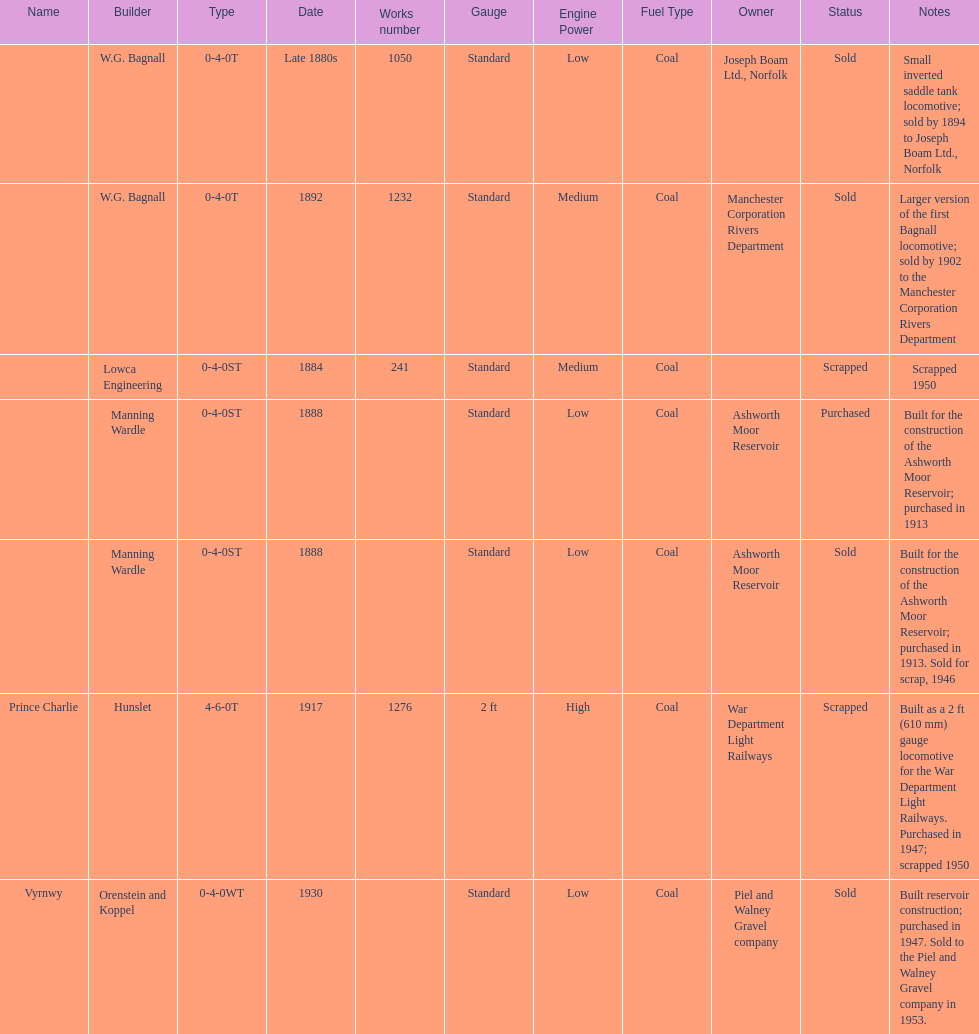How many locomotives were built before the 1900s? 5. Can you give me this table as a dict? {'header': ['Name', 'Builder', 'Type', 'Date', 'Works number', 'Gauge', 'Engine Power', 'Fuel Type', 'Owner', 'Status', 'Notes'], 'rows': [['', 'W.G. Bagnall', '0-4-0T', 'Late 1880s', '1050', 'Standard', 'Low', 'Coal', 'Joseph Boam Ltd., Norfolk', 'Sold', 'Small inverted saddle tank locomotive; sold by 1894 to Joseph Boam Ltd., Norfolk'], ['', 'W.G. Bagnall', '0-4-0T', '1892', '1232', 'Standard', 'Medium', 'Coal', 'Manchester Corporation Rivers Department', 'Sold', 'Larger version of the first Bagnall locomotive; sold by 1902 to the Manchester Corporation Rivers Department'], ['', 'Lowca Engineering', '0-4-0ST', '1884', '241', 'Standard', 'Medium', 'Coal', '', 'Scrapped', 'Scrapped 1950'], ['', 'Manning Wardle', '0-4-0ST', '1888', '', 'Standard', 'Low', 'Coal', 'Ashworth Moor Reservoir', 'Purchased', 'Built for the construction of the Ashworth Moor Reservoir; purchased in 1913'], ['', 'Manning Wardle', '0-4-0ST', '1888', '', 'Standard', 'Low', 'Coal', 'Ashworth Moor Reservoir', 'Sold', 'Built for the construction of the Ashworth Moor Reservoir; purchased in 1913. Sold for scrap, 1946'], ['Prince Charlie', 'Hunslet', '4-6-0T', '1917', '1276', '2 ft', 'High', 'Coal', 'War Department Light Railways', 'Scrapped', 'Built as a 2\xa0ft (610\xa0mm) gauge locomotive for the War Department Light Railways. Purchased in 1947; scrapped 1950'], ['Vyrnwy', 'Orenstein and Koppel', '0-4-0WT', '1930', '', 'Standard', 'Low', 'Coal', 'Piel and Walney Gravel company', 'Sold', 'Built reservoir construction; purchased in 1947. Sold to the Piel and Walney Gravel company in 1953.']]} 